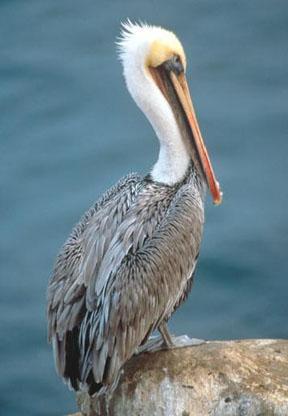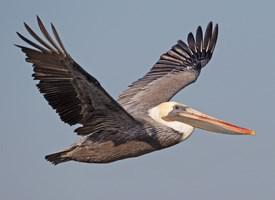The first image is the image on the left, the second image is the image on the right. For the images shown, is this caption "A bird is perched on a rock." true? Answer yes or no. Yes. The first image is the image on the left, the second image is the image on the right. Examine the images to the left and right. Is the description "Two long-beaked birds are shown in flight, both with wings outspread, but one with them pointed downward, and the other with them pointed upward." accurate? Answer yes or no. No. 